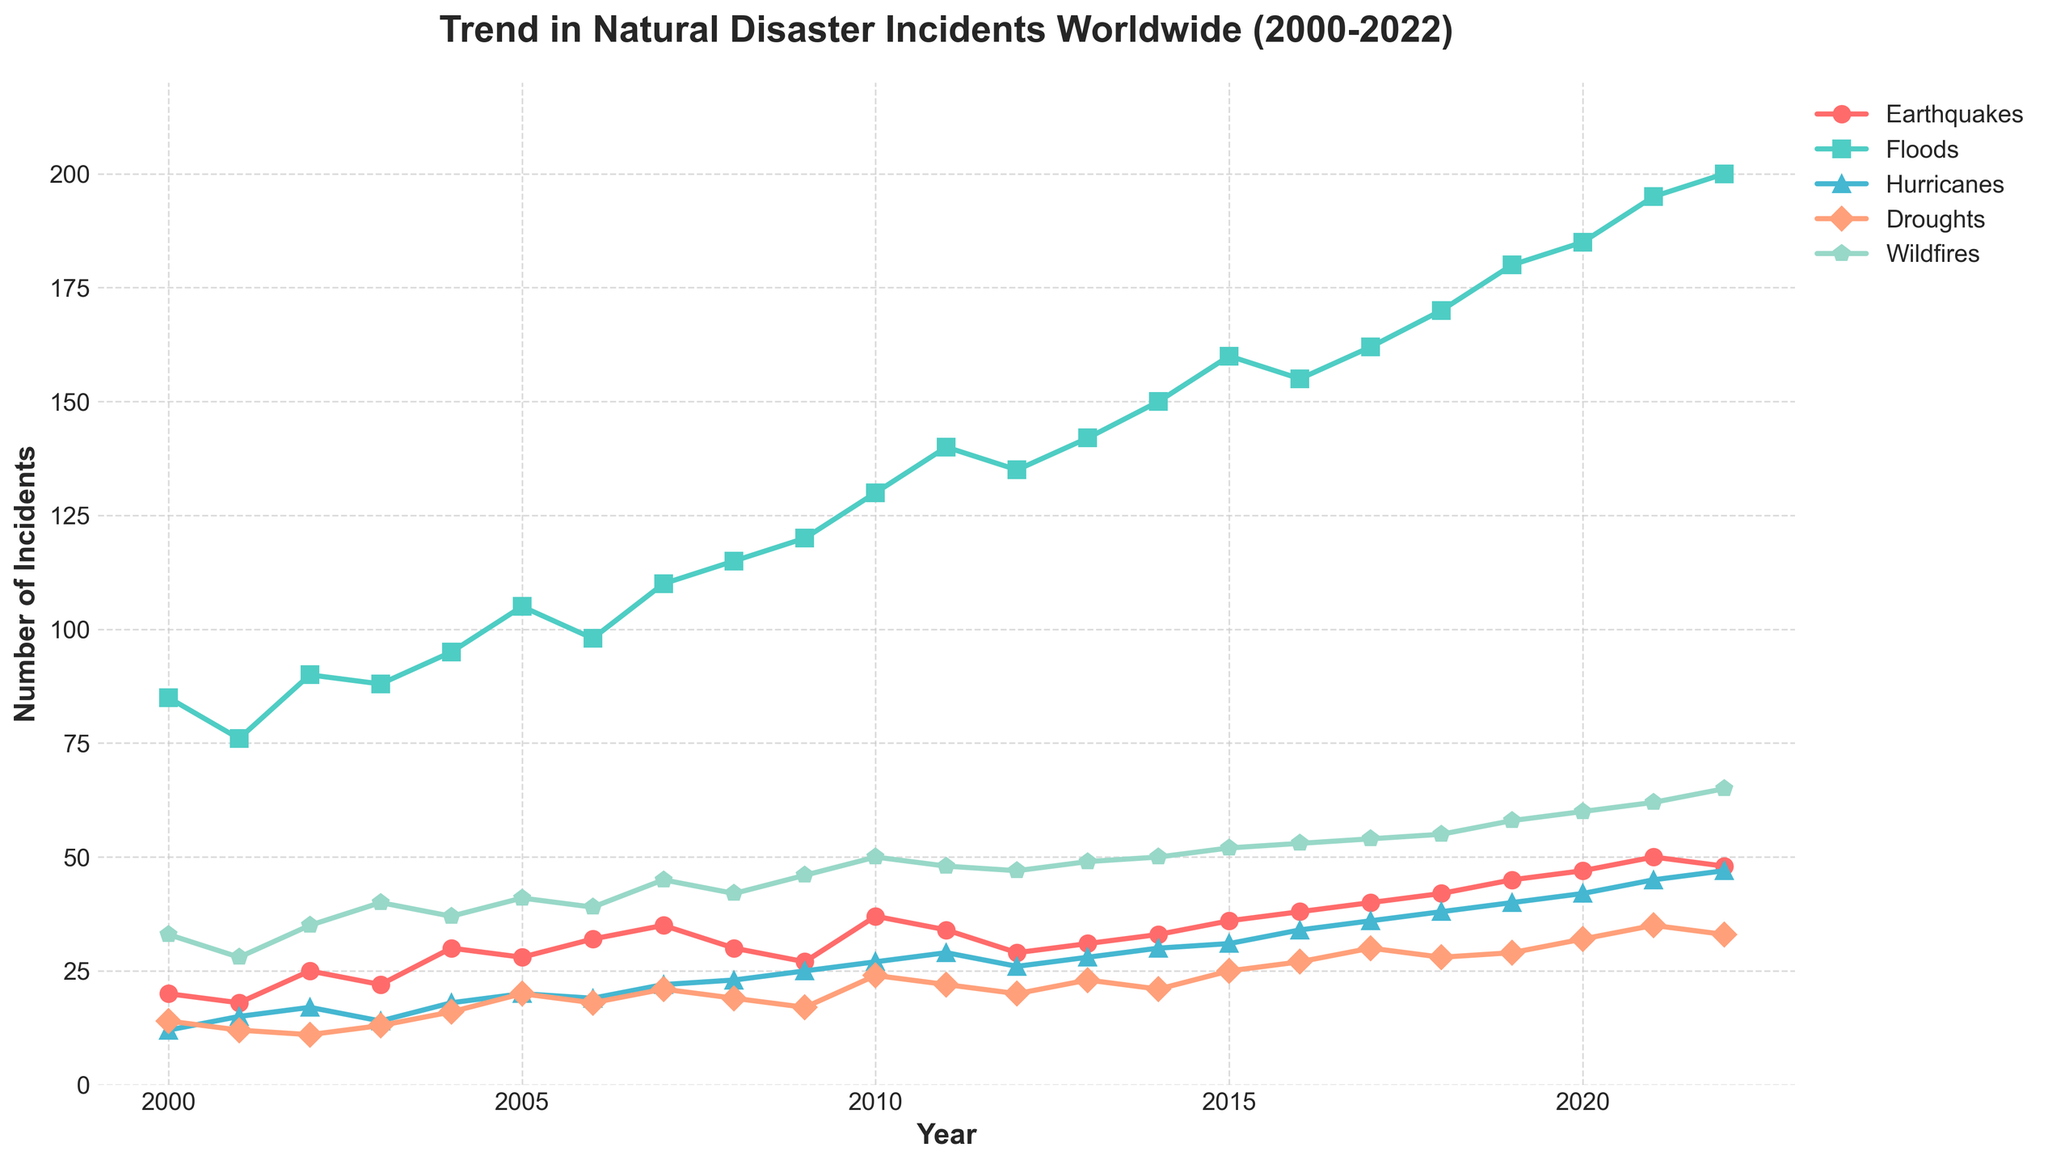What is the title of the figure? The title is usually located at the top of the figure, which gives a brief description of what the figure represents. In this case, the title is 'Trend in Natural Disaster Incidents Worldwide (2000-2022)'.
Answer: Trend in Natural Disaster Incidents Worldwide (2000-2022) What types of natural disasters are tracked in the figure? The types of natural disasters can be identified from the legend or the labels on the lines in the plot. In this figure, the disasters tracked are Earthquakes, Floods, Hurricanes, Droughts, and Wildfires.
Answer: Earthquakes, Floods, Hurricanes, Droughts, Wildfires Which year has the highest number of flood incidents? Locate the line corresponding to floods in the figure (usually color-coded and labeled). Look for the peak point on that line. The highest number of flood incidents is in the year 2022.
Answer: 2022 How many earthquake incidents were recorded in 2010? Find the point on the Earthquakes line corresponding to the year 2010. The number of earthquake incidents recorded in 2010 is 37.
Answer: 37 Which type of disaster shows the most significant upward trend from 2000 to 2022? Analyze each line's slope or trend direction from 2000 to 2022. Floods show the most significant upward trend as the line increases the most sharply over the period.
Answer: Floods What is the difference in the number of hurricane incidents between 2000 and 2022? Locate the points on the Hurricanes line for the years 2000 and 2022. The values are 12 in 2000 and 47 in 2022. The difference is 47 - 12 = 35.
Answer: 35 How many total wildfire incidents were recorded in 2016 and 2020 combined? Find the values on the Wildfires line for the years 2016 and 2020, which are 53 and 60, respectively. Adding these values gives 53 + 60 = 113.
Answer: 113 Which year experienced the lowest number of drought incidents? Look for the minimum value on the Droughts line. The lowest number of drought incidents is in the year 2002 with 11 incidents.
Answer: 2002 Are there any years where all five disasters increased in incidents compared to the previous year? Compare consecutive years for all five disaster types. The year 2017 shows an increase in the number of incidents for all five disaster types compared to 2016.
Answer: 2017 What is the average number of flood incidents recorded between 2010 and 2014? Sum the values on the Floods line for 2010-2014 (130, 140, 135, 142, 150) and divide by the number of years (5). The calculation is (130+140+135+142+150)/5 = 139.4.
Answer: 139.4 